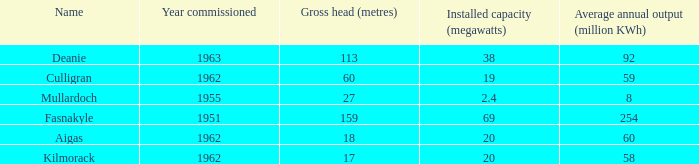What is the earliest Year commissioned wiht an Average annual output greater than 58 and Installed capacity of 20? 1962.0. Parse the table in full. {'header': ['Name', 'Year commissioned', 'Gross head (metres)', 'Installed capacity (megawatts)', 'Average annual output (million KWh)'], 'rows': [['Deanie', '1963', '113', '38', '92'], ['Culligran', '1962', '60', '19', '59'], ['Mullardoch', '1955', '27', '2.4', '8'], ['Fasnakyle', '1951', '159', '69', '254'], ['Aigas', '1962', '18', '20', '60'], ['Kilmorack', '1962', '17', '20', '58']]} 